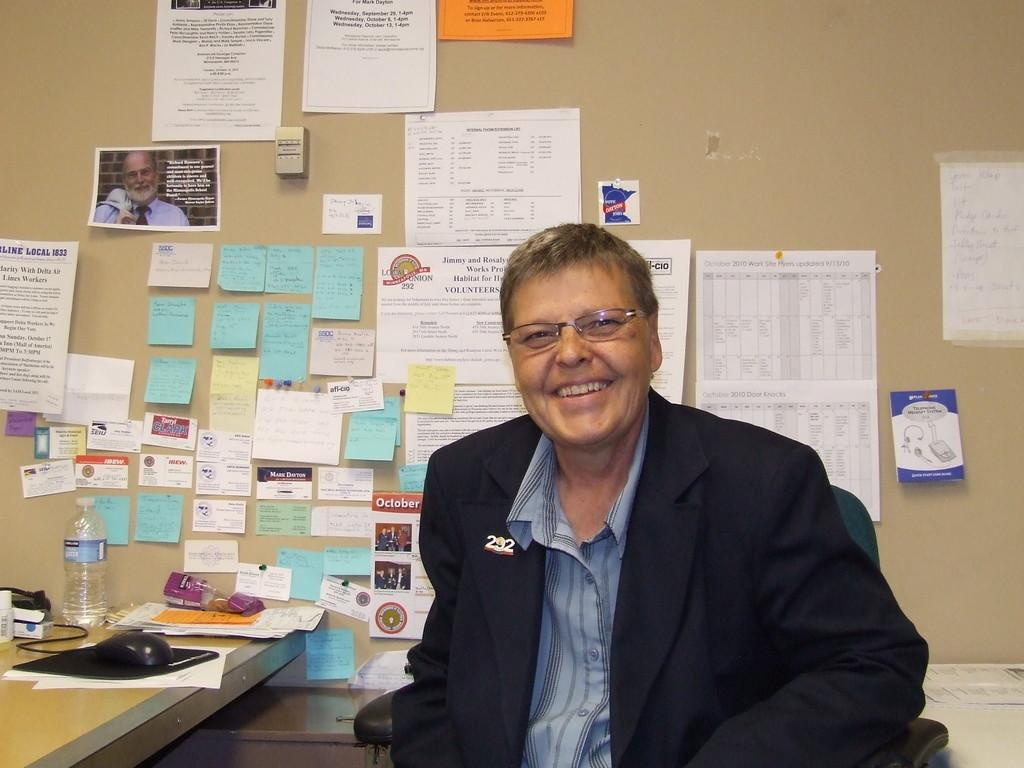What is the man in the image doing? The man is sitting in a chair. What can be seen in the background of the image? There is a table in the background. What is on the table in the image? There is a mouse, a bottle, and papers on the table. Are there any additional items on the wall in the image? Yes, there are sticky notes on the wall. How many balls are visible in the image? There are no balls visible in the image. What type of suggestion is the man giving in the image? The image does not depict the man giving any suggestions; he is simply sitting in a chair. 